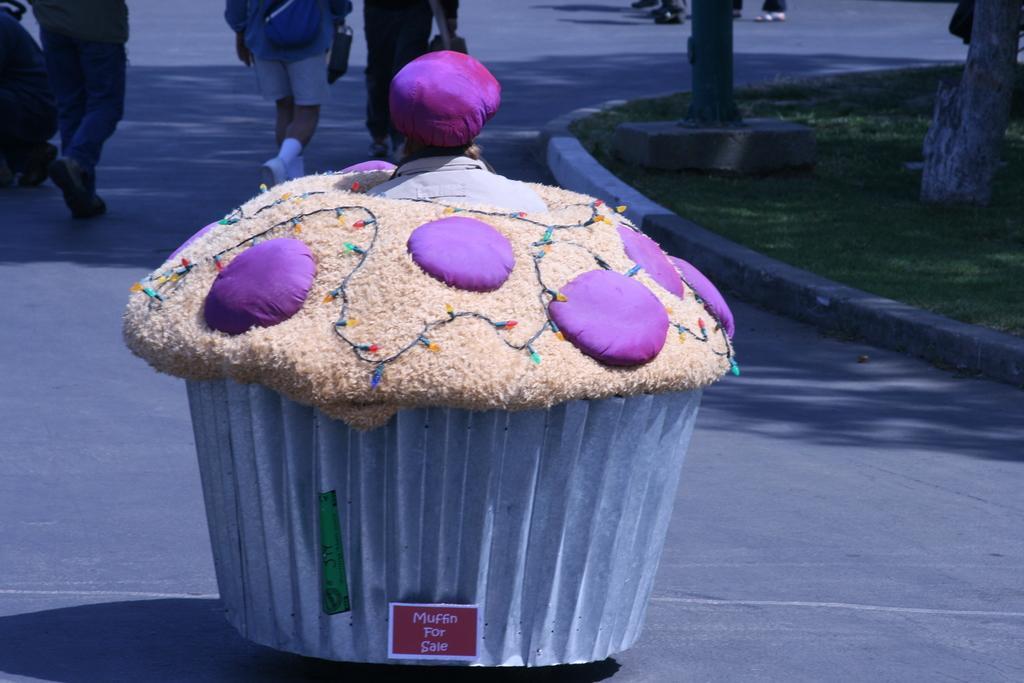How would you summarize this image in a sentence or two? In this picture there is a model of muffin in the center of the image, it seems to be there is a girl inside a muffin and there are people, trees, and grassland in the background area of the image. 